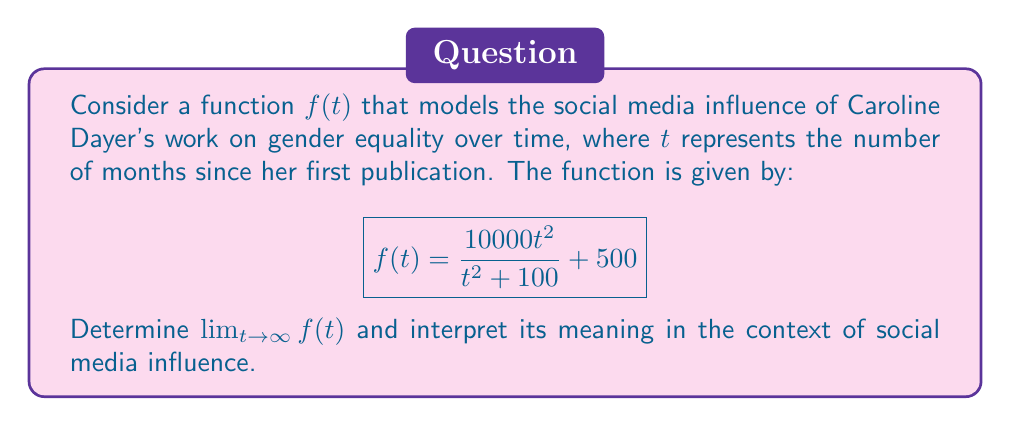Teach me how to tackle this problem. To find the limit of $f(t)$ as $t$ approaches infinity, we'll follow these steps:

1) First, let's examine the structure of the function:
   $$f(t) = \frac{10000t^2}{t^2 + 100} + 500$$

2) As $t$ approaches infinity, both the numerator and denominator of the fraction will grow very large. In such cases, we can determine the limit by comparing the highest degree terms in the numerator and denominator.

3) Both the numerator and denominator have $t^2$ as their highest degree term. When this occurs, we can find the limit by dividing the coefficients of these highest degree terms:

   $$\lim_{t \to \infty} \frac{10000t^2}{t^2 + 100} = \frac{10000}{1} = 10000$$

4) Now, we can evaluate the full limit:

   $$\lim_{t \to \infty} f(t) = \lim_{t \to \infty} (\frac{10000t^2}{t^2 + 100} + 500)$$
   $$= \lim_{t \to \infty} \frac{10000t^2}{t^2 + 100} + \lim_{t \to \infty} 500$$
   $$= 10000 + 500 = 10500$$

5) Interpretation: This limit suggests that as time progresses indefinitely, Caroline Dayer's social media influence approaches a maximum of 10,500 units (which could represent followers, shares, or a composite influence score). The model predicts a saturation point in her online influence related to her work on gender equality.
Answer: $\lim_{t \to \infty} f(t) = 10500$ 